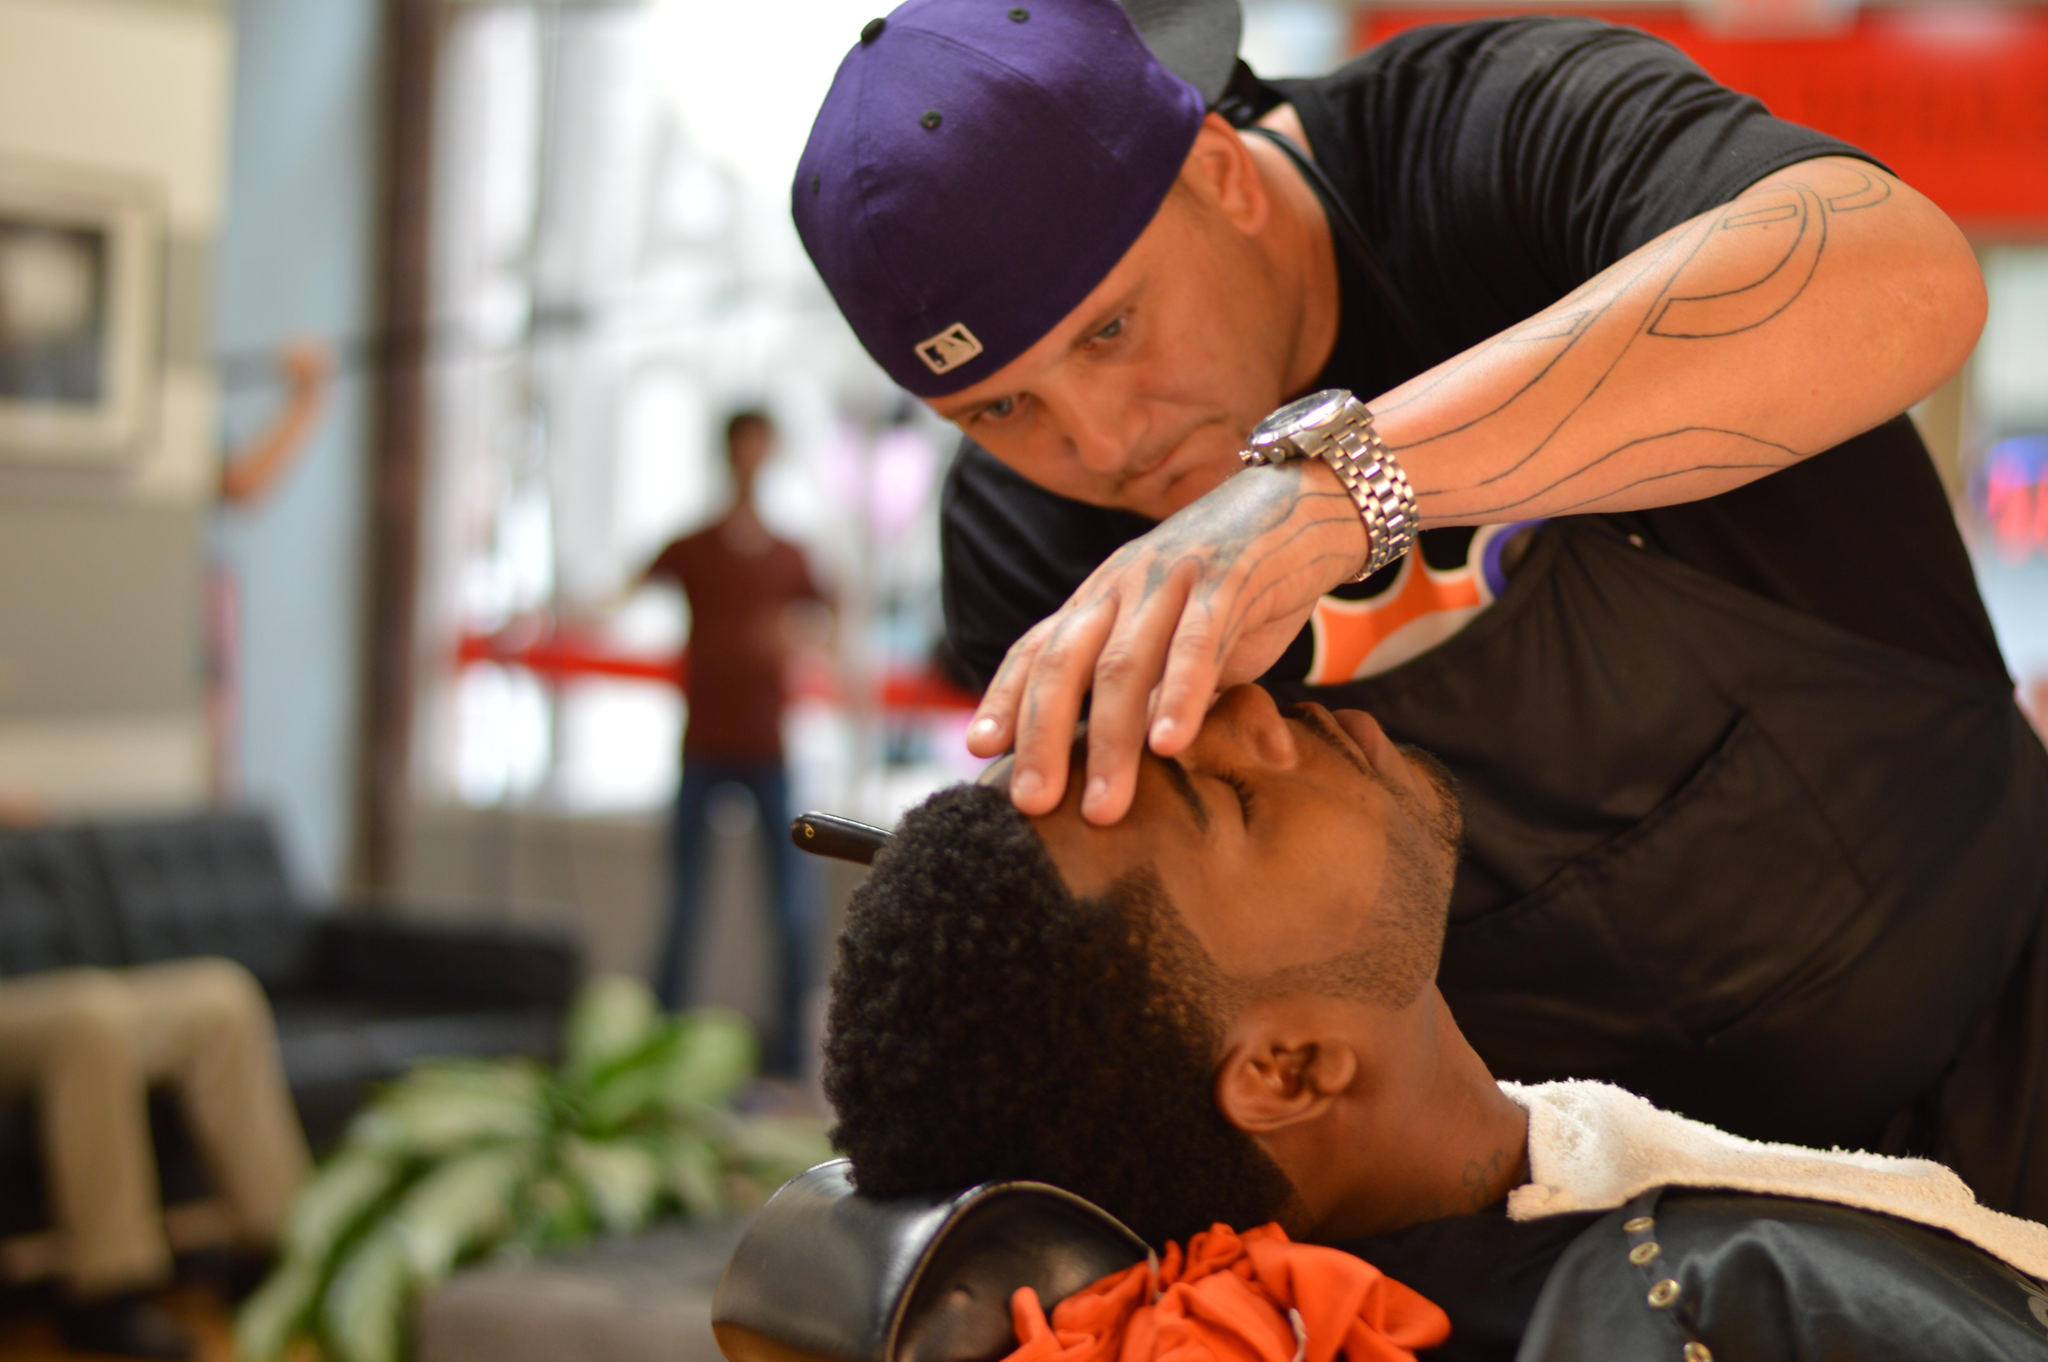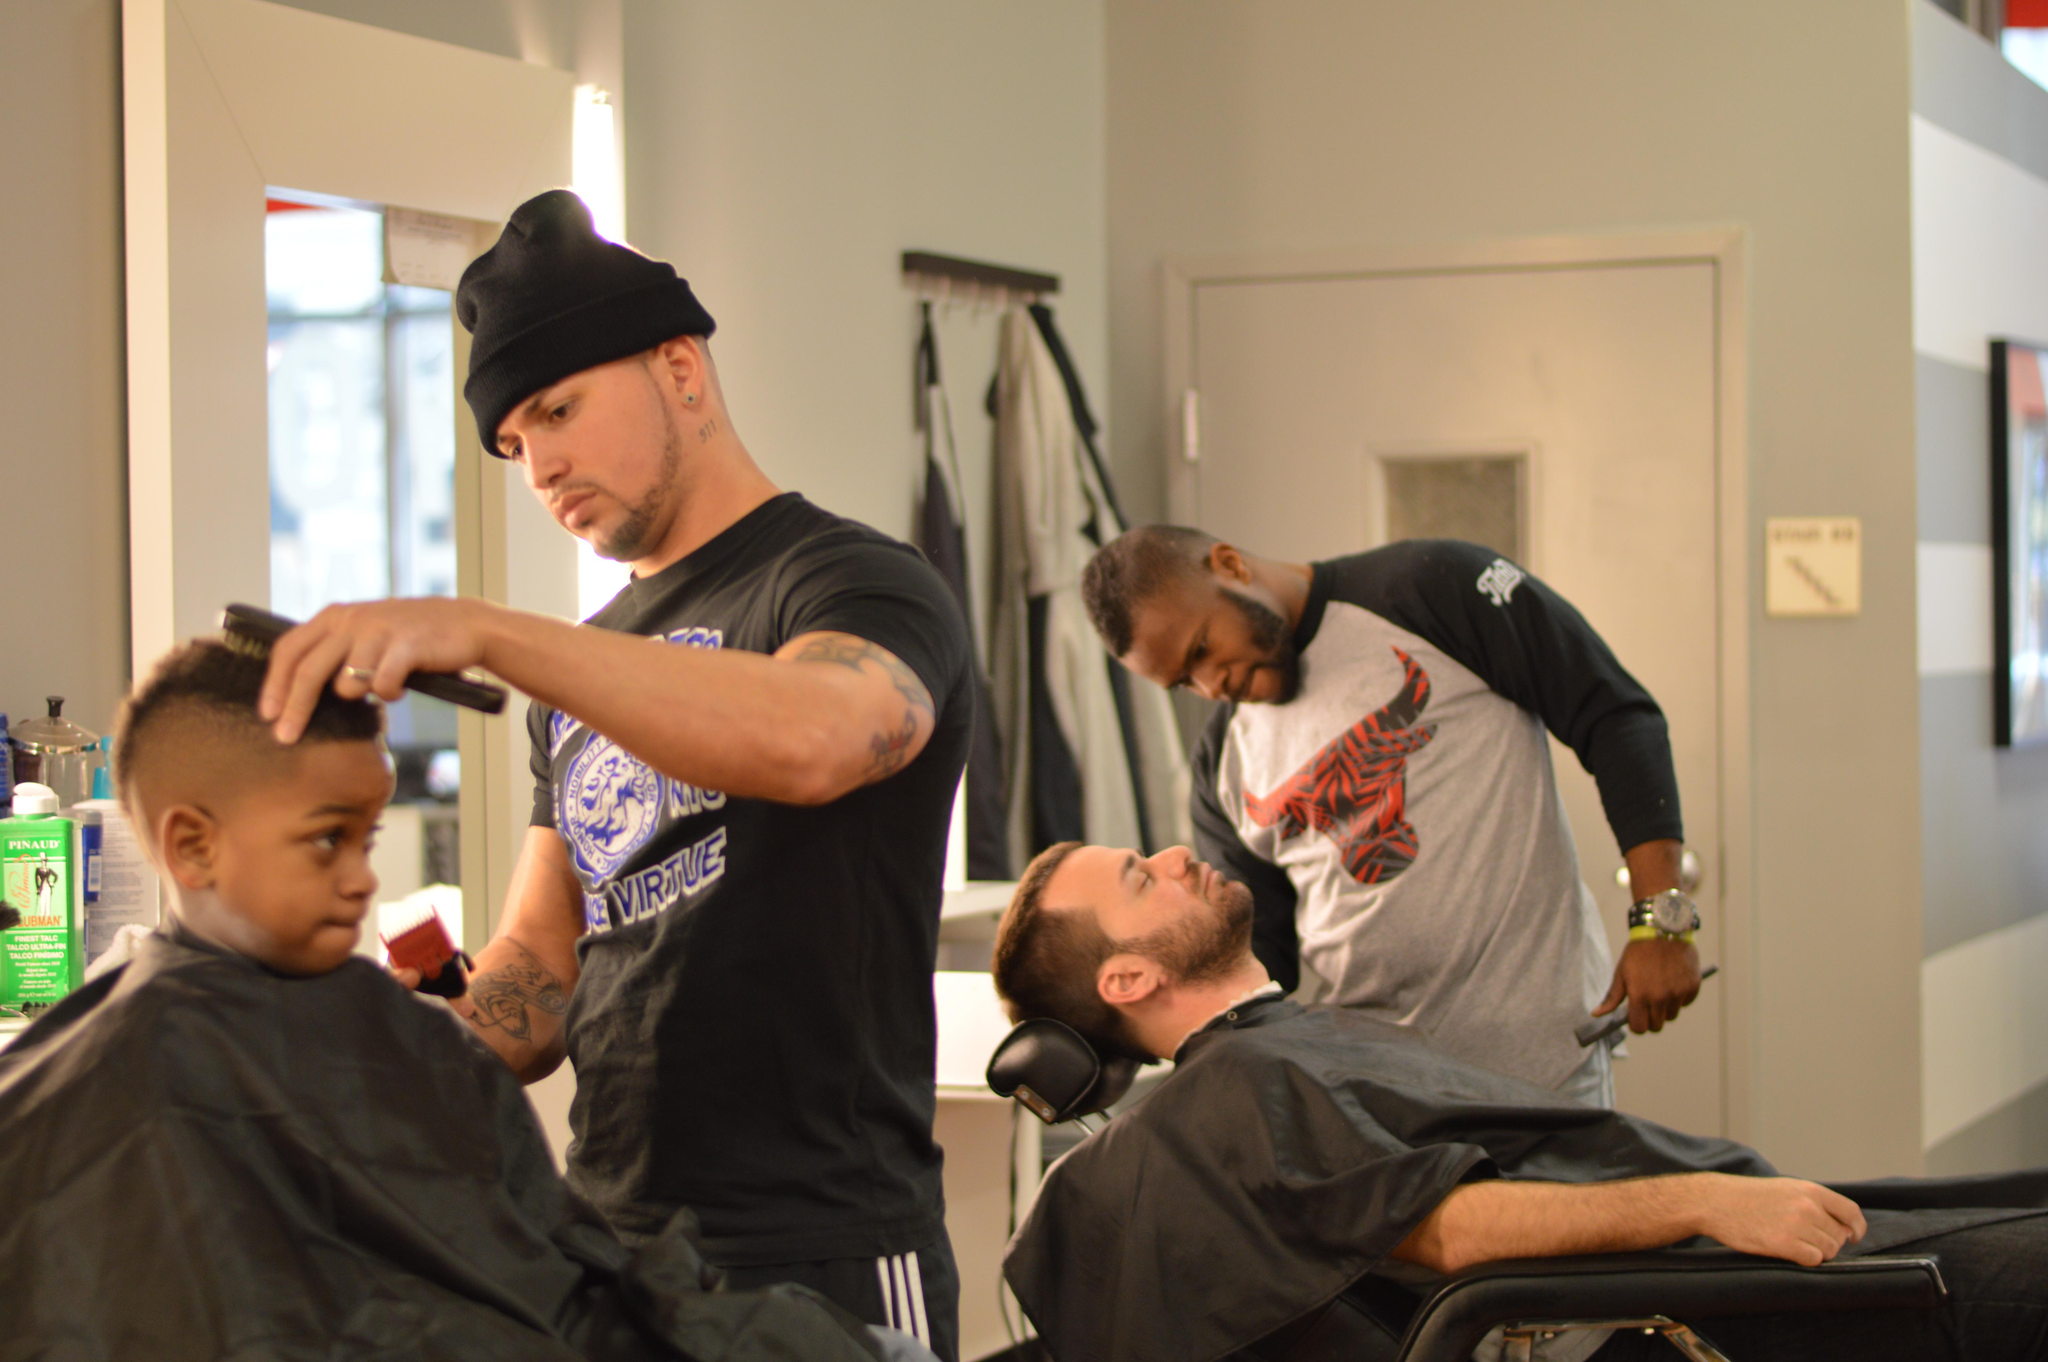The first image is the image on the left, the second image is the image on the right. Evaluate the accuracy of this statement regarding the images: "There are three barbers in total.". Is it true? Answer yes or no. Yes. The first image is the image on the left, the second image is the image on the right. Evaluate the accuracy of this statement regarding the images: "There are exactly four people.". Is it true? Answer yes or no. No. 